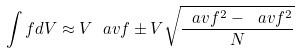<formula> <loc_0><loc_0><loc_500><loc_500>\int f d V \approx V \ a v { f } \pm V \sqrt { \frac { \ a v { f ^ { 2 } } - \ a v { f } ^ { 2 } } { N } }</formula> 